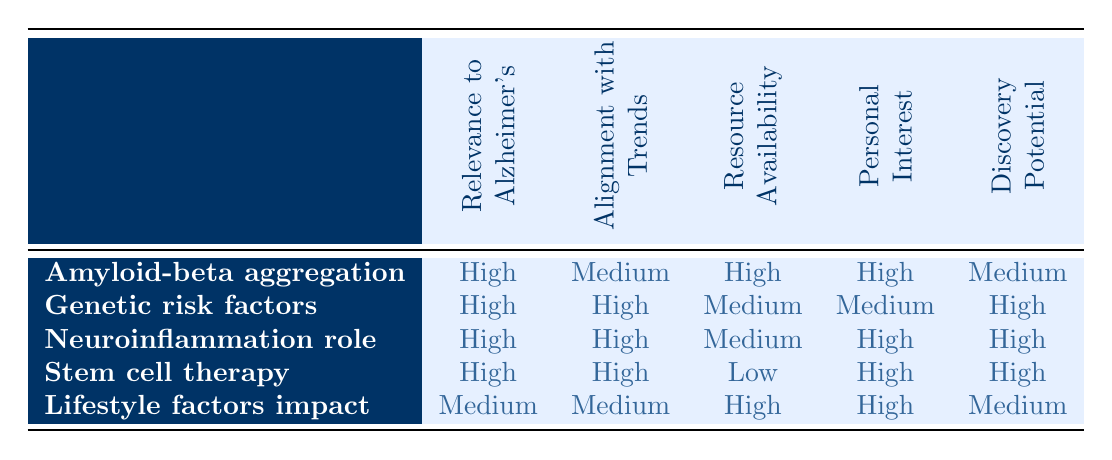What is the primary relevance of the "Role of neuroinflammation in Alzheimer's progression"? The table indicates that the "Role of neuroinflammation in Alzheimer's progression" has a "High" relevance to Alzheimer's research, as noted in the second column under this specific option.
Answer: High Which research topic has the highest potential for groundbreaking discoveries? The table shows two topics with "High" potential for groundbreaking discoveries: "Genetic risk factors for early-onset Alzheimer's" and "Potential of stem cell therapy in Alzheimer's treatment", both indicated in the last column.
Answer: Genetic risk factors for early-onset Alzheimer's and Potential of stem cell therapy in Alzheimer's treatment Is the "Impact of lifestyle factors on Alzheimer's prevention" aligned with current scientific trends? The table states that the "Impact of lifestyle factors on Alzheimer's prevention" has "Medium" alignment with current scientific trends, which can be found in the third column corresponding to this option.
Answer: Medium Which research topic has low availability of resources but high personal interest? Referencing the table, "Potential of stem cell therapy in Alzheimer's treatment" is labeled with "Low" availability of resources and "High" personal interest, as seen in the third and fourth columns under this option.
Answer: Potential of stem cell therapy in Alzheimer's treatment Which research topic is both highly relevant and highly aligned with current scientific trends? From the table, the topics "Genetic risk factors for early-onset Alzheimer's" and "Role of neuroinflammation in Alzheimer's progression" both have "High" ratings for relevance and alignment with trends, found under rows two and three respectively.
Answer: Genetic risk factors for early-onset Alzheimer's and Role of neuroinflammation in Alzheimer's progression 